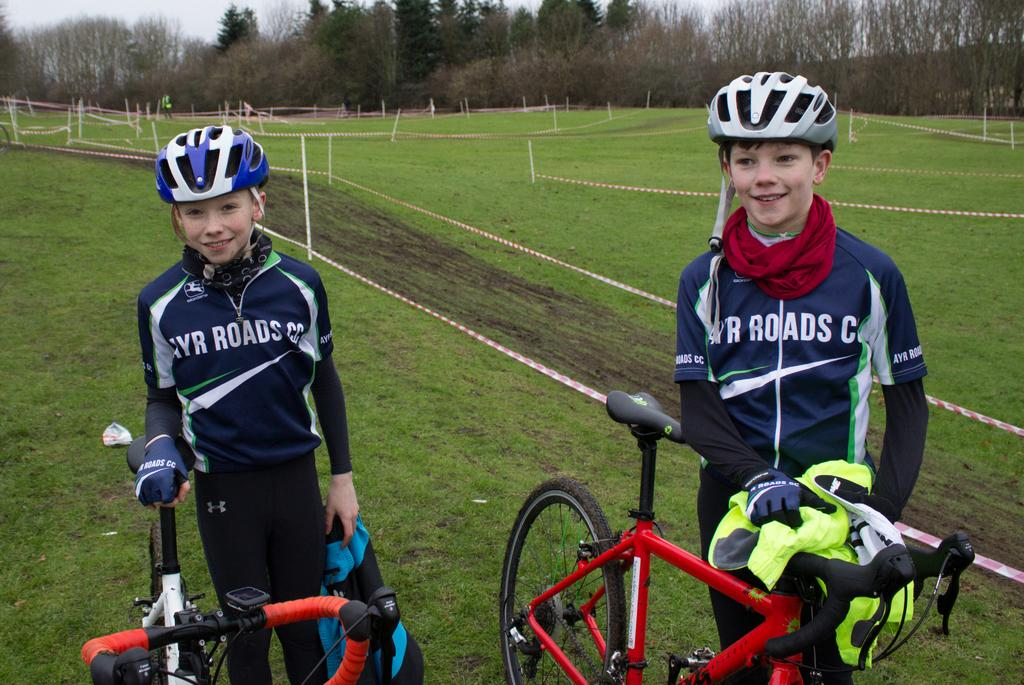How many people are in the image? There are two people in the image. What are the people holding in the image? The people are holding bicycles. What type of natural environment can be seen in the image? There are trees visible in the image. What grade does the aunt give to the ice sculpture in the image? There is no ice sculpture or aunt present in the image. 